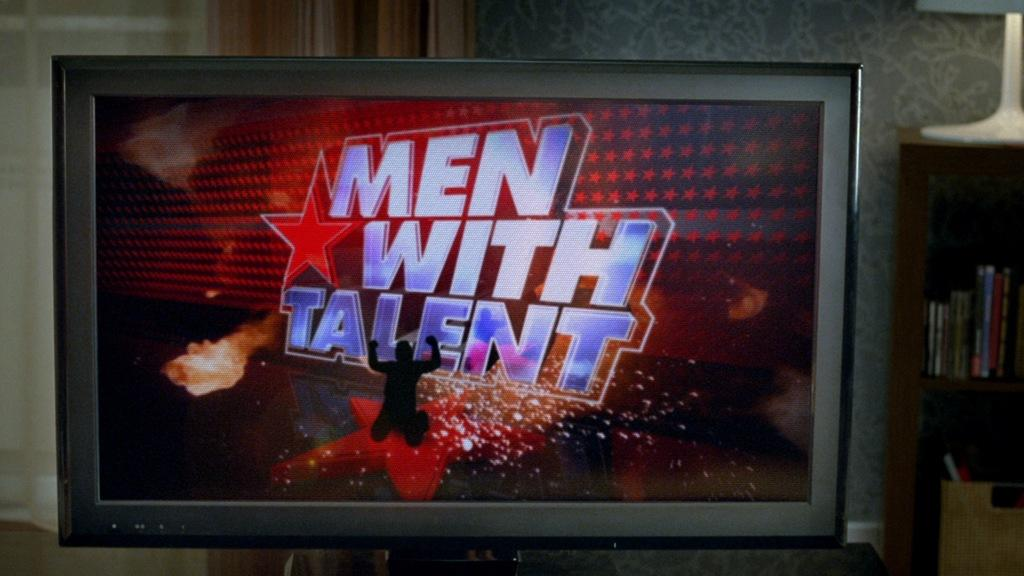Provide a one-sentence caption for the provided image. a television that says men with talent on it. 